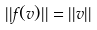Convert formula to latex. <formula><loc_0><loc_0><loc_500><loc_500>| | f ( v ) | | = | | v | |</formula> 